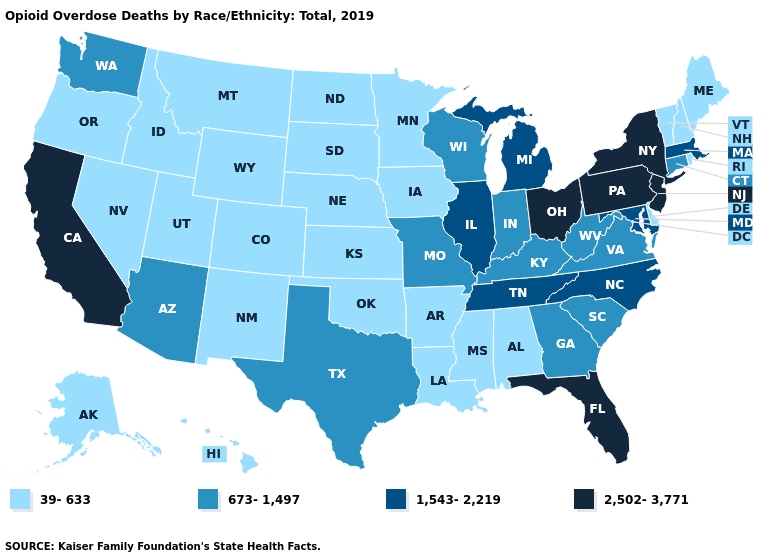Does Tennessee have a higher value than Montana?
Keep it brief. Yes. What is the highest value in states that border Indiana?
Answer briefly. 2,502-3,771. Does Michigan have a higher value than New Jersey?
Concise answer only. No. Which states have the lowest value in the USA?
Give a very brief answer. Alabama, Alaska, Arkansas, Colorado, Delaware, Hawaii, Idaho, Iowa, Kansas, Louisiana, Maine, Minnesota, Mississippi, Montana, Nebraska, Nevada, New Hampshire, New Mexico, North Dakota, Oklahoma, Oregon, Rhode Island, South Dakota, Utah, Vermont, Wyoming. Which states have the lowest value in the MidWest?
Keep it brief. Iowa, Kansas, Minnesota, Nebraska, North Dakota, South Dakota. What is the value of Nebraska?
Give a very brief answer. 39-633. What is the lowest value in the USA?
Quick response, please. 39-633. Which states have the lowest value in the West?
Short answer required. Alaska, Colorado, Hawaii, Idaho, Montana, Nevada, New Mexico, Oregon, Utah, Wyoming. Does Kansas have the lowest value in the MidWest?
Be succinct. Yes. Does Pennsylvania have the highest value in the Northeast?
Answer briefly. Yes. Name the states that have a value in the range 39-633?
Answer briefly. Alabama, Alaska, Arkansas, Colorado, Delaware, Hawaii, Idaho, Iowa, Kansas, Louisiana, Maine, Minnesota, Mississippi, Montana, Nebraska, Nevada, New Hampshire, New Mexico, North Dakota, Oklahoma, Oregon, Rhode Island, South Dakota, Utah, Vermont, Wyoming. What is the highest value in states that border Iowa?
Short answer required. 1,543-2,219. Does California have the lowest value in the USA?
Write a very short answer. No. What is the highest value in the USA?
Short answer required. 2,502-3,771. Name the states that have a value in the range 2,502-3,771?
Concise answer only. California, Florida, New Jersey, New York, Ohio, Pennsylvania. 